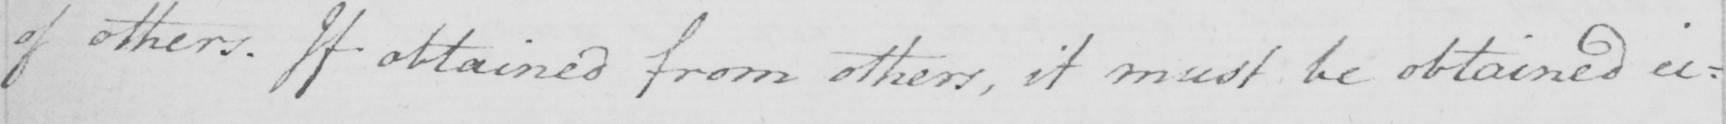Can you read and transcribe this handwriting? of others . If obtained from others , it must be obtained ei : 